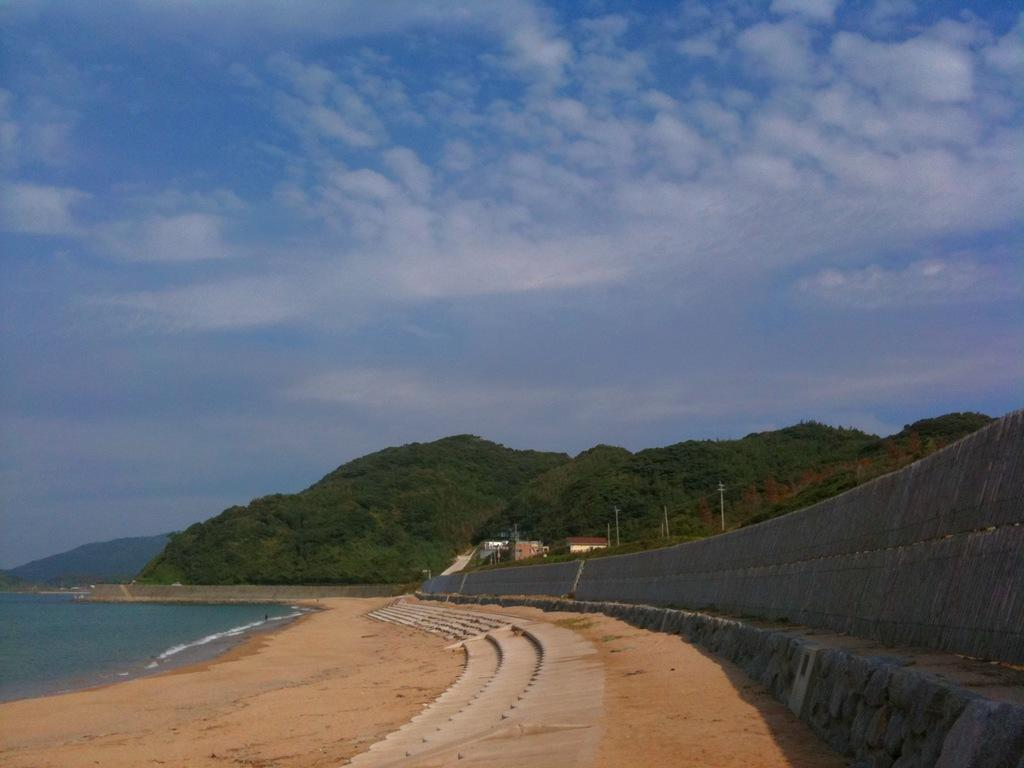What type of structure can be seen in the image? There is a bridge in the image. What other objects can be seen in the image? There are poles, houses, trees, and hills visible in the image. What is the condition of the sky in the image? There are clouds in the sky in the image. What natural elements are present in the image? There is water and ground visible in the image. How many chickens are present in the image? There are no chickens present in the image. What type of control system is used to manage the water flow in the image? There is no control system mentioned or visible in the image. 